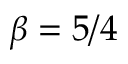<formula> <loc_0><loc_0><loc_500><loc_500>\beta = 5 / 4</formula> 